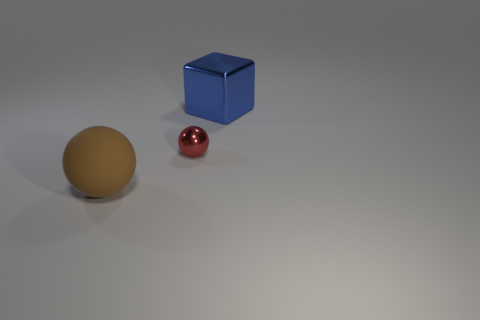How many metal things are either balls or big objects?
Provide a succinct answer. 2. There is another tiny metal thing that is the same shape as the brown object; what is its color?
Make the answer very short. Red. What number of objects are large blue metallic objects or small yellow matte cubes?
Your answer should be very brief. 1. What is the shape of the blue object that is made of the same material as the small ball?
Ensure brevity in your answer.  Cube. How many large objects are either metal balls or green cubes?
Make the answer very short. 0. How many other things are there of the same color as the big metal object?
Offer a very short reply. 0. There is a large thing in front of the ball that is behind the rubber sphere; how many spheres are to the right of it?
Your answer should be compact. 1. Do the metallic object in front of the blue thing and the brown matte sphere have the same size?
Your answer should be very brief. No. Are there fewer metallic things right of the tiny sphere than big metallic cubes that are right of the shiny block?
Ensure brevity in your answer.  No. Is the rubber thing the same color as the big block?
Your answer should be compact. No. 